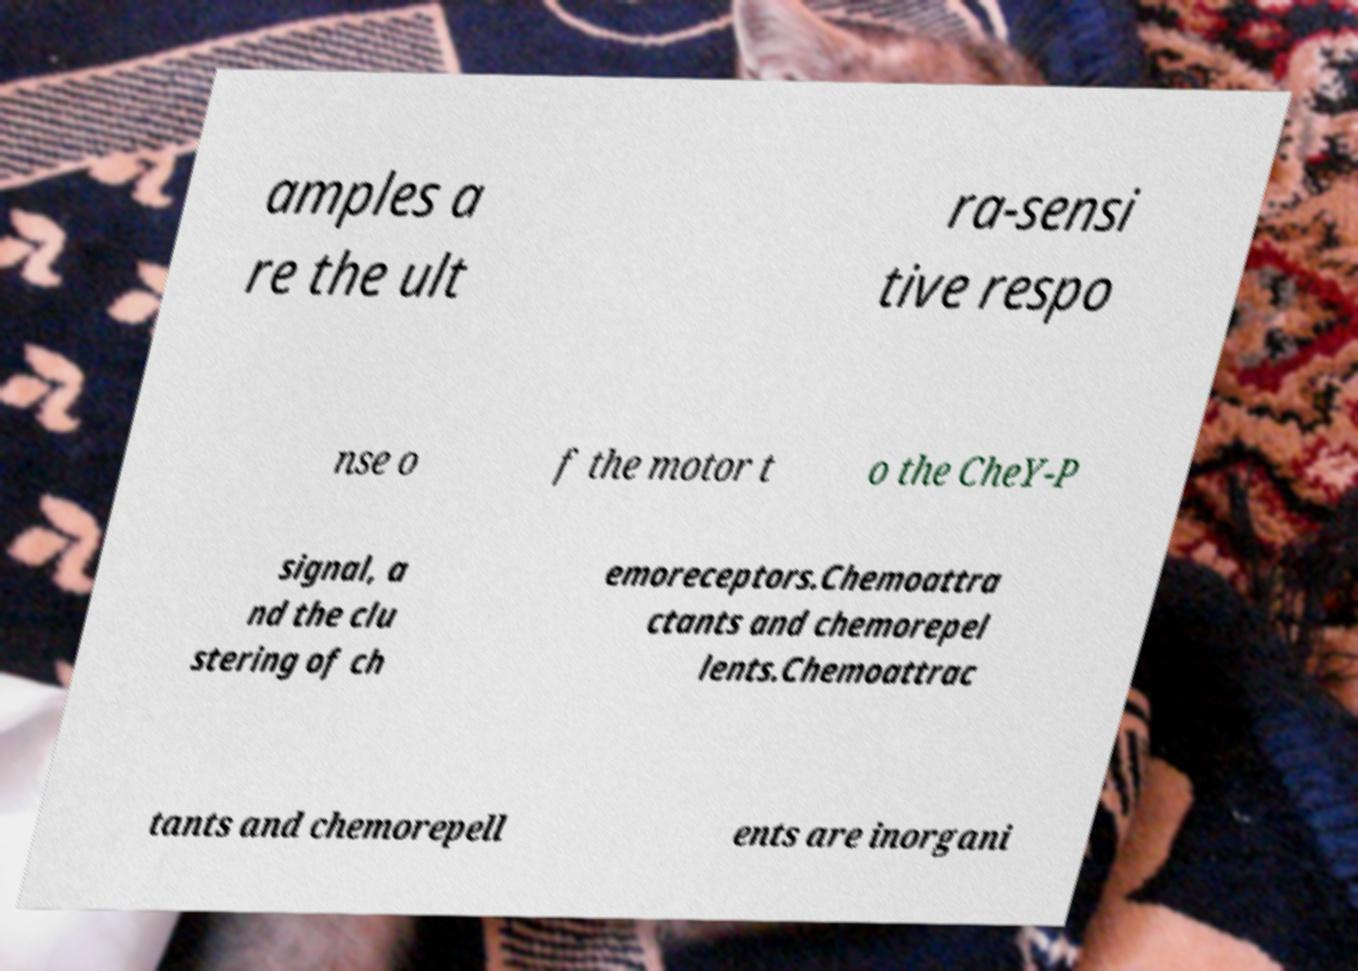I need the written content from this picture converted into text. Can you do that? amples a re the ult ra-sensi tive respo nse o f the motor t o the CheY-P signal, a nd the clu stering of ch emoreceptors.Chemoattra ctants and chemorepel lents.Chemoattrac tants and chemorepell ents are inorgani 